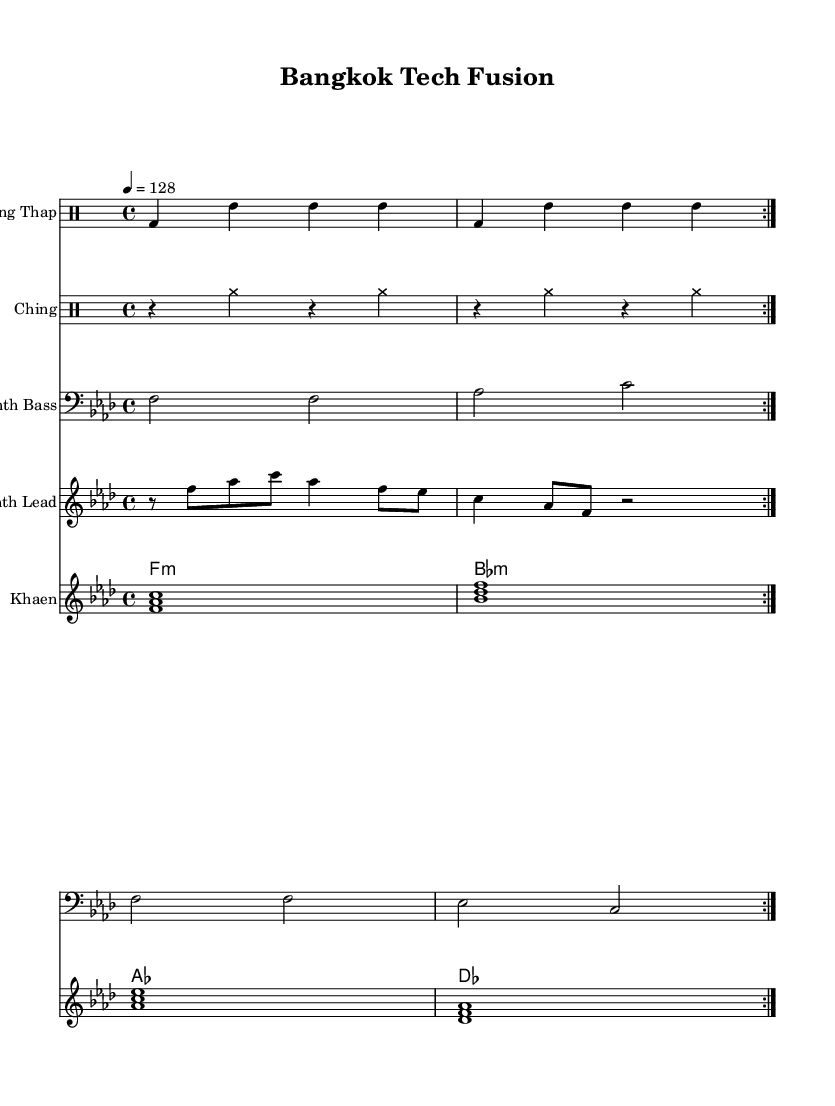What is the key signature of this music? The key signature marked in the score shows F minor, which has four flats (B♭, E♭, A♭, D♭). The key signature is indicated at the beginning of the staff lines.
Answer: F minor What is the time signature of the piece? The time signature displayed at the beginning of the score is 4/4, meaning there are four beats in each measure and a quarter note receives one beat. This is a common time signature in house music.
Answer: 4/4 What is the tempo marking for this piece? The tempo marking of 4 = 128 indicates the speed of the piece, meaning there are 128 beats per minute. This pacing is typical for house music, enhancing its danceability.
Answer: 128 How many measures are repeated for the Klong Thap? The Klong Thap section is set to repeat twice as indicated by the "volta 2" directive in the drummode section, meaning it will be played twice before moving on.
Answer: 2 What instruments are used in this score? The score features several instruments: Klong Thap, Ching, Synth Bass, Synth Lead, and Khaen, which are common in fusions of traditional Thai music with modern electronic beats.
Answer: Klong Thap, Ching, Synth Bass, Synth Lead, Khaen What is the first note played in the Synth Lead? The first note of the Synth Lead is F, which is indicated in the notation shown above where the relative note positioning starts with F.
Answer: F What kind of music does this sheet represent? The sheet music represents a fusion of tech house and traditional Thai music, evident in the use of electronic instruments alongside traditional Thai percussion like Klong Thap and Khaen.
Answer: Tech house 